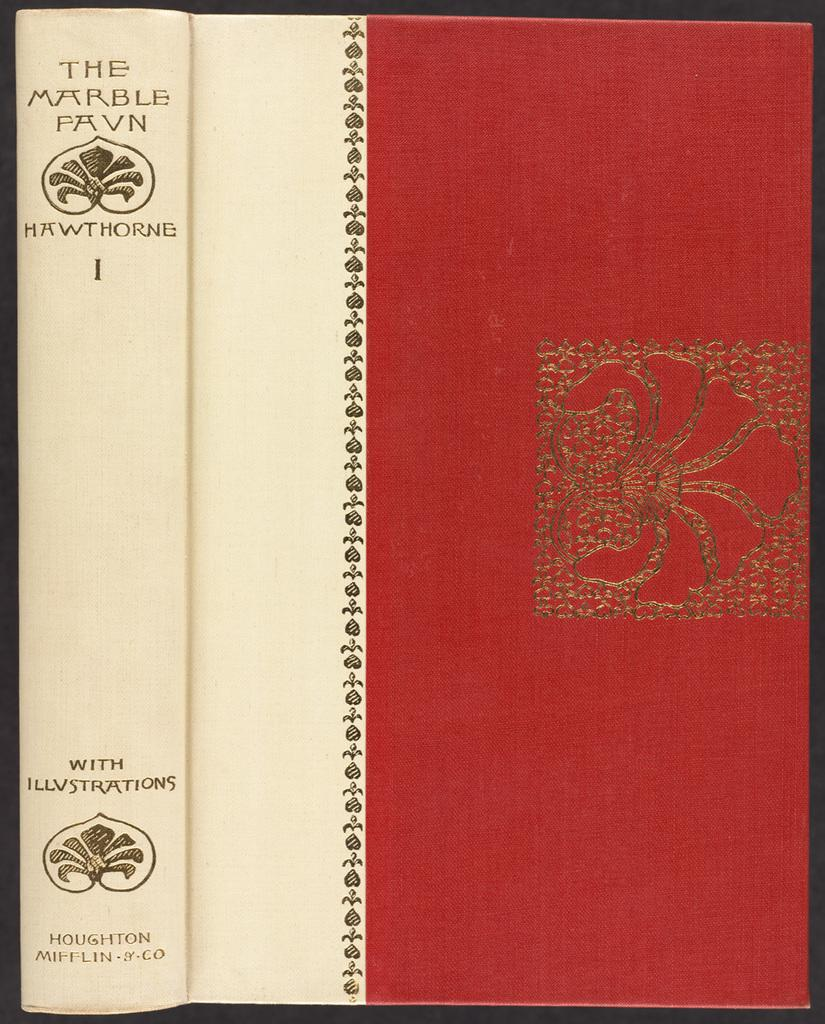<image>
Summarize the visual content of the image. A book titled " The Marble Favn" with illustrations and Hawthorne. 